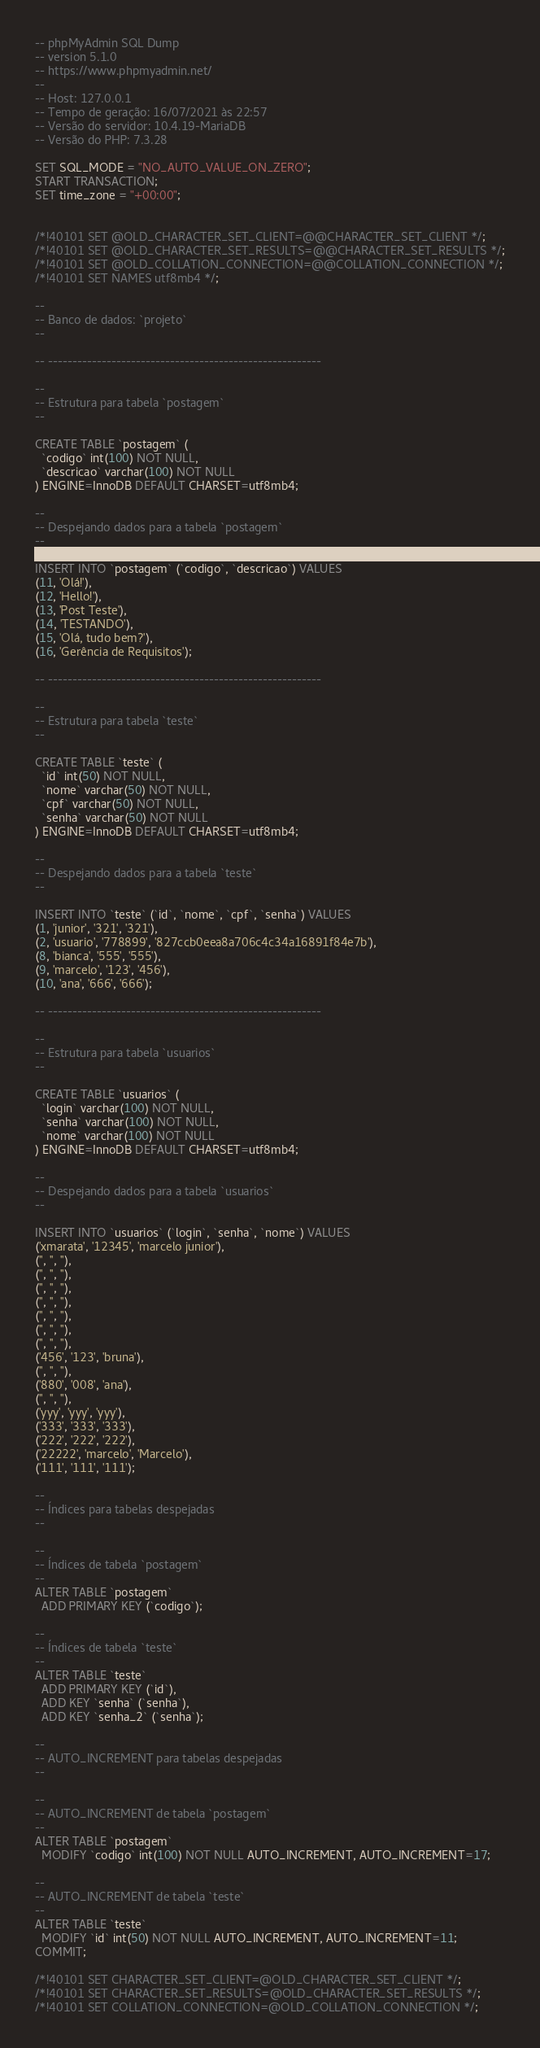<code> <loc_0><loc_0><loc_500><loc_500><_SQL_>-- phpMyAdmin SQL Dump
-- version 5.1.0
-- https://www.phpmyadmin.net/
--
-- Host: 127.0.0.1
-- Tempo de geração: 16/07/2021 às 22:57
-- Versão do servidor: 10.4.19-MariaDB
-- Versão do PHP: 7.3.28

SET SQL_MODE = "NO_AUTO_VALUE_ON_ZERO";
START TRANSACTION;
SET time_zone = "+00:00";


/*!40101 SET @OLD_CHARACTER_SET_CLIENT=@@CHARACTER_SET_CLIENT */;
/*!40101 SET @OLD_CHARACTER_SET_RESULTS=@@CHARACTER_SET_RESULTS */;
/*!40101 SET @OLD_COLLATION_CONNECTION=@@COLLATION_CONNECTION */;
/*!40101 SET NAMES utf8mb4 */;

--
-- Banco de dados: `projeto`
--

-- --------------------------------------------------------

--
-- Estrutura para tabela `postagem`
--

CREATE TABLE `postagem` (
  `codigo` int(100) NOT NULL,
  `descricao` varchar(100) NOT NULL
) ENGINE=InnoDB DEFAULT CHARSET=utf8mb4;

--
-- Despejando dados para a tabela `postagem`
--

INSERT INTO `postagem` (`codigo`, `descricao`) VALUES
(11, 'Olá!'),
(12, 'Hello!'),
(13, 'Post Teste'),
(14, 'TESTANDO'),
(15, 'Olá, tudo bem?'),
(16, 'Gerência de Requisitos');

-- --------------------------------------------------------

--
-- Estrutura para tabela `teste`
--

CREATE TABLE `teste` (
  `id` int(50) NOT NULL,
  `nome` varchar(50) NOT NULL,
  `cpf` varchar(50) NOT NULL,
  `senha` varchar(50) NOT NULL
) ENGINE=InnoDB DEFAULT CHARSET=utf8mb4;

--
-- Despejando dados para a tabela `teste`
--

INSERT INTO `teste` (`id`, `nome`, `cpf`, `senha`) VALUES
(1, 'junior', '321', '321'),
(2, 'usuario', '778899', '827ccb0eea8a706c4c34a16891f84e7b'),
(8, 'bianca', '555', '555'),
(9, 'marcelo', '123', '456'),
(10, 'ana', '666', '666');

-- --------------------------------------------------------

--
-- Estrutura para tabela `usuarios`
--

CREATE TABLE `usuarios` (
  `login` varchar(100) NOT NULL,
  `senha` varchar(100) NOT NULL,
  `nome` varchar(100) NOT NULL
) ENGINE=InnoDB DEFAULT CHARSET=utf8mb4;

--
-- Despejando dados para a tabela `usuarios`
--

INSERT INTO `usuarios` (`login`, `senha`, `nome`) VALUES
('xmarata', '12345', 'marcelo junior'),
('', '', ''),
('', '', ''),
('', '', ''),
('', '', ''),
('', '', ''),
('', '', ''),
('', '', ''),
('456', '123', 'bruna'),
('', '', ''),
('880', '008', 'ana'),
('', '', ''),
('yyy', 'yyy', 'yyy'),
('333', '333', '333'),
('222', '222', '222'),
('22222', 'marcelo', 'Marcelo'),
('111', '111', '111');

--
-- Índices para tabelas despejadas
--

--
-- Índices de tabela `postagem`
--
ALTER TABLE `postagem`
  ADD PRIMARY KEY (`codigo`);

--
-- Índices de tabela `teste`
--
ALTER TABLE `teste`
  ADD PRIMARY KEY (`id`),
  ADD KEY `senha` (`senha`),
  ADD KEY `senha_2` (`senha`);

--
-- AUTO_INCREMENT para tabelas despejadas
--

--
-- AUTO_INCREMENT de tabela `postagem`
--
ALTER TABLE `postagem`
  MODIFY `codigo` int(100) NOT NULL AUTO_INCREMENT, AUTO_INCREMENT=17;

--
-- AUTO_INCREMENT de tabela `teste`
--
ALTER TABLE `teste`
  MODIFY `id` int(50) NOT NULL AUTO_INCREMENT, AUTO_INCREMENT=11;
COMMIT;

/*!40101 SET CHARACTER_SET_CLIENT=@OLD_CHARACTER_SET_CLIENT */;
/*!40101 SET CHARACTER_SET_RESULTS=@OLD_CHARACTER_SET_RESULTS */;
/*!40101 SET COLLATION_CONNECTION=@OLD_COLLATION_CONNECTION */;
</code> 